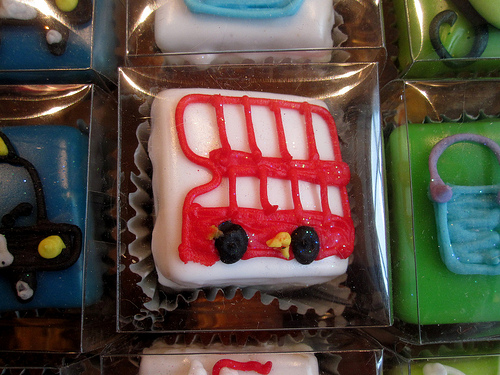<image>
Can you confirm if the bus is above the duck? No. The bus is not positioned above the duck. The vertical arrangement shows a different relationship. Is there a bus on the cupcake? Yes. Looking at the image, I can see the bus is positioned on top of the cupcake, with the cupcake providing support. 